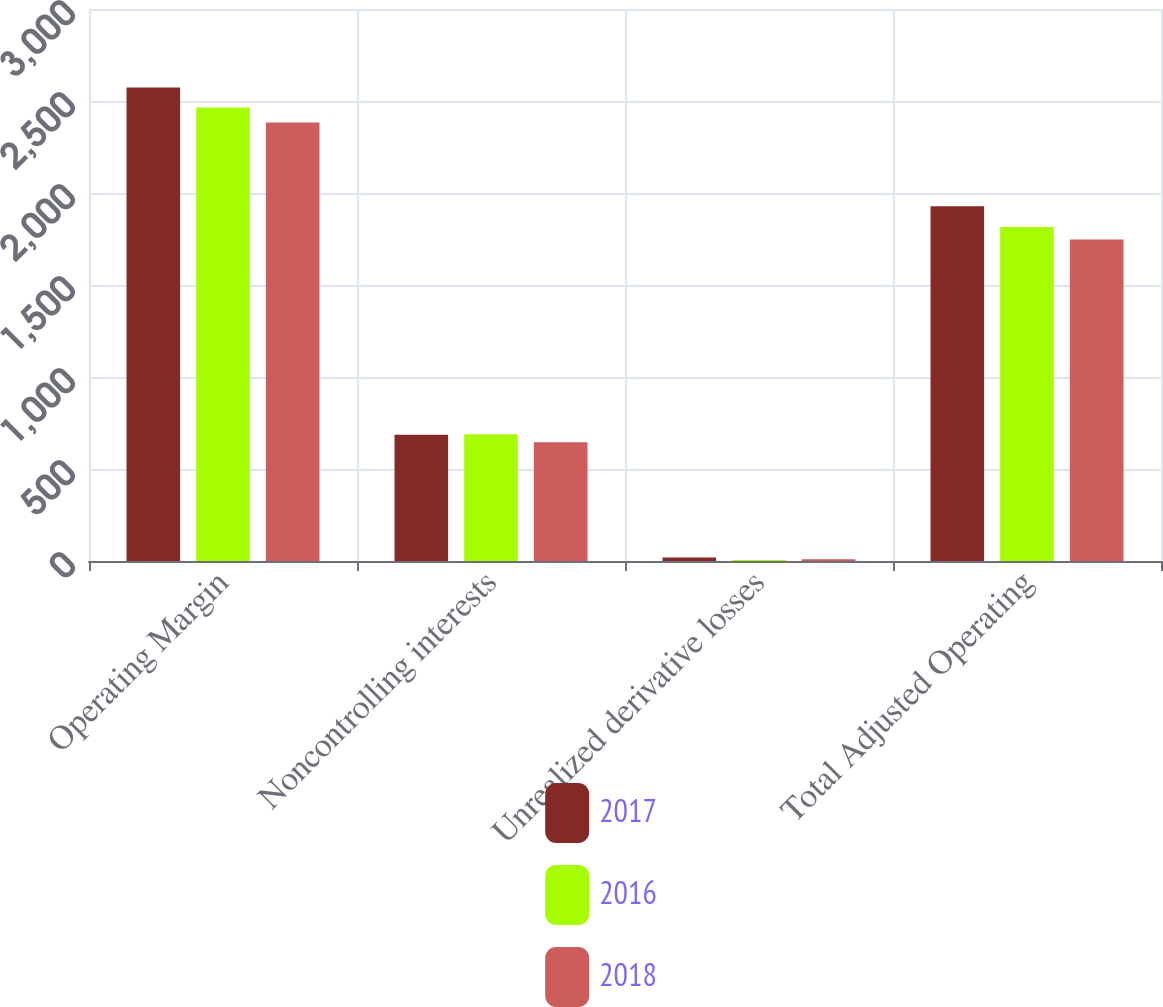Convert chart to OTSL. <chart><loc_0><loc_0><loc_500><loc_500><stacked_bar_chart><ecel><fcel>Operating Margin<fcel>Noncontrolling interests<fcel>Unrealized derivative losses<fcel>Total Adjusted Operating<nl><fcel>2017<fcel>2573<fcel>686<fcel>19<fcel>1928<nl><fcel>2016<fcel>2465<fcel>689<fcel>5<fcel>1815<nl><fcel>2018<fcel>2383<fcel>645<fcel>9<fcel>1747<nl></chart> 